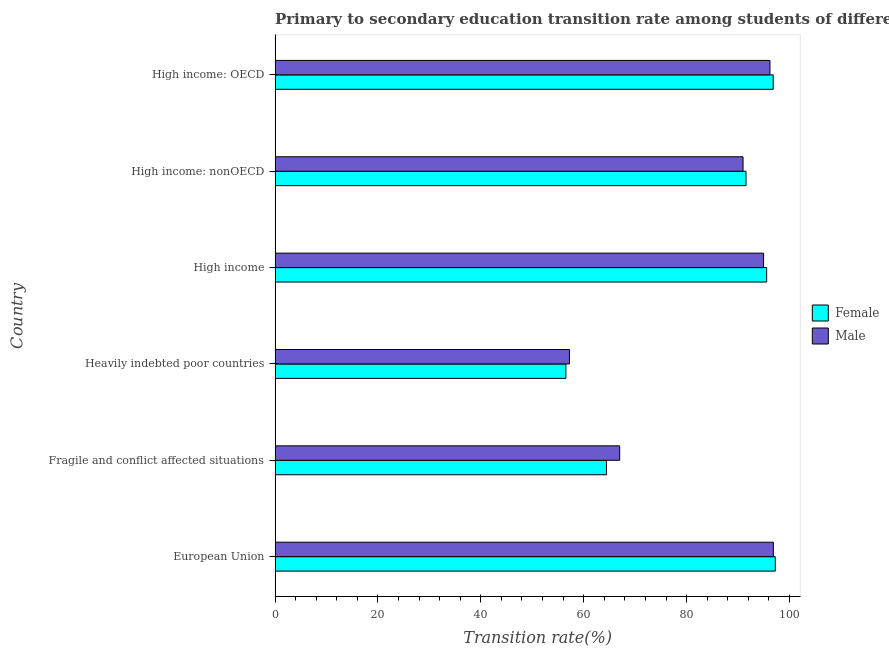How many different coloured bars are there?
Your answer should be compact. 2. How many groups of bars are there?
Give a very brief answer. 6. Are the number of bars per tick equal to the number of legend labels?
Offer a very short reply. Yes. How many bars are there on the 2nd tick from the top?
Offer a terse response. 2. What is the label of the 1st group of bars from the top?
Keep it short and to the point. High income: OECD. In how many cases, is the number of bars for a given country not equal to the number of legend labels?
Provide a short and direct response. 0. What is the transition rate among male students in High income: nonOECD?
Offer a very short reply. 90.97. Across all countries, what is the maximum transition rate among male students?
Make the answer very short. 96.87. Across all countries, what is the minimum transition rate among male students?
Provide a short and direct response. 57.23. In which country was the transition rate among female students minimum?
Keep it short and to the point. Heavily indebted poor countries. What is the total transition rate among female students in the graph?
Ensure brevity in your answer.  502.15. What is the difference between the transition rate among female students in Fragile and conflict affected situations and that in Heavily indebted poor countries?
Offer a very short reply. 7.88. What is the difference between the transition rate among female students in High income and the transition rate among male students in High income: OECD?
Provide a short and direct response. -0.64. What is the average transition rate among male students per country?
Make the answer very short. 83.87. What is the difference between the transition rate among female students and transition rate among male students in Heavily indebted poor countries?
Offer a terse response. -0.69. In how many countries, is the transition rate among female students greater than 96 %?
Your answer should be compact. 2. What is the ratio of the transition rate among female students in European Union to that in Heavily indebted poor countries?
Give a very brief answer. 1.72. Is the difference between the transition rate among female students in Fragile and conflict affected situations and High income: nonOECD greater than the difference between the transition rate among male students in Fragile and conflict affected situations and High income: nonOECD?
Offer a very short reply. No. What is the difference between the highest and the second highest transition rate among female students?
Keep it short and to the point. 0.41. What is the difference between the highest and the lowest transition rate among female students?
Offer a terse response. 40.71. Is the sum of the transition rate among male students in Heavily indebted poor countries and High income: nonOECD greater than the maximum transition rate among female students across all countries?
Your answer should be very brief. Yes. What does the 1st bar from the top in European Union represents?
Your answer should be very brief. Male. What does the 1st bar from the bottom in High income: OECD represents?
Give a very brief answer. Female. How many bars are there?
Keep it short and to the point. 12. Are all the bars in the graph horizontal?
Offer a very short reply. Yes. Are the values on the major ticks of X-axis written in scientific E-notation?
Your response must be concise. No. Where does the legend appear in the graph?
Keep it short and to the point. Center right. How are the legend labels stacked?
Your answer should be compact. Vertical. What is the title of the graph?
Offer a very short reply. Primary to secondary education transition rate among students of different countries. What is the label or title of the X-axis?
Your response must be concise. Transition rate(%). What is the label or title of the Y-axis?
Your response must be concise. Country. What is the Transition rate(%) of Female in European Union?
Make the answer very short. 97.24. What is the Transition rate(%) in Male in European Union?
Provide a succinct answer. 96.87. What is the Transition rate(%) of Female in Fragile and conflict affected situations?
Ensure brevity in your answer.  64.42. What is the Transition rate(%) of Male in Fragile and conflict affected situations?
Make the answer very short. 66.99. What is the Transition rate(%) of Female in Heavily indebted poor countries?
Keep it short and to the point. 56.54. What is the Transition rate(%) of Male in Heavily indebted poor countries?
Your answer should be compact. 57.23. What is the Transition rate(%) in Female in High income?
Provide a succinct answer. 95.56. What is the Transition rate(%) of Male in High income?
Offer a very short reply. 94.96. What is the Transition rate(%) of Female in High income: nonOECD?
Give a very brief answer. 91.55. What is the Transition rate(%) in Male in High income: nonOECD?
Your answer should be very brief. 90.97. What is the Transition rate(%) of Female in High income: OECD?
Provide a short and direct response. 96.84. What is the Transition rate(%) in Male in High income: OECD?
Make the answer very short. 96.2. Across all countries, what is the maximum Transition rate(%) in Female?
Provide a short and direct response. 97.24. Across all countries, what is the maximum Transition rate(%) of Male?
Ensure brevity in your answer.  96.87. Across all countries, what is the minimum Transition rate(%) of Female?
Give a very brief answer. 56.54. Across all countries, what is the minimum Transition rate(%) in Male?
Ensure brevity in your answer.  57.23. What is the total Transition rate(%) of Female in the graph?
Ensure brevity in your answer.  502.15. What is the total Transition rate(%) of Male in the graph?
Offer a terse response. 503.22. What is the difference between the Transition rate(%) of Female in European Union and that in Fragile and conflict affected situations?
Your answer should be very brief. 32.82. What is the difference between the Transition rate(%) in Male in European Union and that in Fragile and conflict affected situations?
Offer a very short reply. 29.88. What is the difference between the Transition rate(%) of Female in European Union and that in Heavily indebted poor countries?
Provide a succinct answer. 40.71. What is the difference between the Transition rate(%) in Male in European Union and that in Heavily indebted poor countries?
Your answer should be very brief. 39.64. What is the difference between the Transition rate(%) in Female in European Union and that in High income?
Offer a terse response. 1.68. What is the difference between the Transition rate(%) in Male in European Union and that in High income?
Ensure brevity in your answer.  1.91. What is the difference between the Transition rate(%) of Female in European Union and that in High income: nonOECD?
Make the answer very short. 5.69. What is the difference between the Transition rate(%) of Male in European Union and that in High income: nonOECD?
Your answer should be very brief. 5.89. What is the difference between the Transition rate(%) of Female in European Union and that in High income: OECD?
Your response must be concise. 0.41. What is the difference between the Transition rate(%) in Male in European Union and that in High income: OECD?
Ensure brevity in your answer.  0.66. What is the difference between the Transition rate(%) in Female in Fragile and conflict affected situations and that in Heavily indebted poor countries?
Your answer should be very brief. 7.89. What is the difference between the Transition rate(%) in Male in Fragile and conflict affected situations and that in Heavily indebted poor countries?
Give a very brief answer. 9.76. What is the difference between the Transition rate(%) of Female in Fragile and conflict affected situations and that in High income?
Your answer should be compact. -31.14. What is the difference between the Transition rate(%) of Male in Fragile and conflict affected situations and that in High income?
Make the answer very short. -27.97. What is the difference between the Transition rate(%) in Female in Fragile and conflict affected situations and that in High income: nonOECD?
Keep it short and to the point. -27.13. What is the difference between the Transition rate(%) of Male in Fragile and conflict affected situations and that in High income: nonOECD?
Offer a very short reply. -23.99. What is the difference between the Transition rate(%) in Female in Fragile and conflict affected situations and that in High income: OECD?
Give a very brief answer. -32.42. What is the difference between the Transition rate(%) in Male in Fragile and conflict affected situations and that in High income: OECD?
Provide a short and direct response. -29.22. What is the difference between the Transition rate(%) in Female in Heavily indebted poor countries and that in High income?
Provide a succinct answer. -39.03. What is the difference between the Transition rate(%) in Male in Heavily indebted poor countries and that in High income?
Your answer should be very brief. -37.73. What is the difference between the Transition rate(%) in Female in Heavily indebted poor countries and that in High income: nonOECD?
Offer a terse response. -35.01. What is the difference between the Transition rate(%) in Male in Heavily indebted poor countries and that in High income: nonOECD?
Provide a short and direct response. -33.74. What is the difference between the Transition rate(%) in Female in Heavily indebted poor countries and that in High income: OECD?
Keep it short and to the point. -40.3. What is the difference between the Transition rate(%) of Male in Heavily indebted poor countries and that in High income: OECD?
Your answer should be very brief. -38.97. What is the difference between the Transition rate(%) of Female in High income and that in High income: nonOECD?
Keep it short and to the point. 4.01. What is the difference between the Transition rate(%) of Male in High income and that in High income: nonOECD?
Your response must be concise. 3.99. What is the difference between the Transition rate(%) in Female in High income and that in High income: OECD?
Ensure brevity in your answer.  -1.27. What is the difference between the Transition rate(%) in Male in High income and that in High income: OECD?
Your response must be concise. -1.24. What is the difference between the Transition rate(%) of Female in High income: nonOECD and that in High income: OECD?
Your answer should be compact. -5.29. What is the difference between the Transition rate(%) of Male in High income: nonOECD and that in High income: OECD?
Offer a very short reply. -5.23. What is the difference between the Transition rate(%) of Female in European Union and the Transition rate(%) of Male in Fragile and conflict affected situations?
Offer a terse response. 30.25. What is the difference between the Transition rate(%) in Female in European Union and the Transition rate(%) in Male in Heavily indebted poor countries?
Your answer should be very brief. 40.01. What is the difference between the Transition rate(%) in Female in European Union and the Transition rate(%) in Male in High income?
Offer a very short reply. 2.28. What is the difference between the Transition rate(%) in Female in European Union and the Transition rate(%) in Male in High income: nonOECD?
Your response must be concise. 6.27. What is the difference between the Transition rate(%) in Female in European Union and the Transition rate(%) in Male in High income: OECD?
Make the answer very short. 1.04. What is the difference between the Transition rate(%) in Female in Fragile and conflict affected situations and the Transition rate(%) in Male in Heavily indebted poor countries?
Offer a very short reply. 7.19. What is the difference between the Transition rate(%) in Female in Fragile and conflict affected situations and the Transition rate(%) in Male in High income?
Your answer should be very brief. -30.54. What is the difference between the Transition rate(%) in Female in Fragile and conflict affected situations and the Transition rate(%) in Male in High income: nonOECD?
Keep it short and to the point. -26.55. What is the difference between the Transition rate(%) of Female in Fragile and conflict affected situations and the Transition rate(%) of Male in High income: OECD?
Provide a short and direct response. -31.78. What is the difference between the Transition rate(%) in Female in Heavily indebted poor countries and the Transition rate(%) in Male in High income?
Your answer should be compact. -38.43. What is the difference between the Transition rate(%) in Female in Heavily indebted poor countries and the Transition rate(%) in Male in High income: nonOECD?
Your answer should be compact. -34.44. What is the difference between the Transition rate(%) of Female in Heavily indebted poor countries and the Transition rate(%) of Male in High income: OECD?
Provide a short and direct response. -39.67. What is the difference between the Transition rate(%) in Female in High income and the Transition rate(%) in Male in High income: nonOECD?
Offer a terse response. 4.59. What is the difference between the Transition rate(%) of Female in High income and the Transition rate(%) of Male in High income: OECD?
Keep it short and to the point. -0.64. What is the difference between the Transition rate(%) in Female in High income: nonOECD and the Transition rate(%) in Male in High income: OECD?
Provide a succinct answer. -4.65. What is the average Transition rate(%) in Female per country?
Keep it short and to the point. 83.69. What is the average Transition rate(%) of Male per country?
Your answer should be very brief. 83.87. What is the difference between the Transition rate(%) of Female and Transition rate(%) of Male in European Union?
Ensure brevity in your answer.  0.38. What is the difference between the Transition rate(%) in Female and Transition rate(%) in Male in Fragile and conflict affected situations?
Provide a short and direct response. -2.57. What is the difference between the Transition rate(%) of Female and Transition rate(%) of Male in Heavily indebted poor countries?
Provide a short and direct response. -0.69. What is the difference between the Transition rate(%) of Female and Transition rate(%) of Male in High income?
Make the answer very short. 0.6. What is the difference between the Transition rate(%) in Female and Transition rate(%) in Male in High income: nonOECD?
Make the answer very short. 0.58. What is the difference between the Transition rate(%) of Female and Transition rate(%) of Male in High income: OECD?
Offer a very short reply. 0.63. What is the ratio of the Transition rate(%) of Female in European Union to that in Fragile and conflict affected situations?
Offer a terse response. 1.51. What is the ratio of the Transition rate(%) in Male in European Union to that in Fragile and conflict affected situations?
Your answer should be compact. 1.45. What is the ratio of the Transition rate(%) of Female in European Union to that in Heavily indebted poor countries?
Keep it short and to the point. 1.72. What is the ratio of the Transition rate(%) of Male in European Union to that in Heavily indebted poor countries?
Ensure brevity in your answer.  1.69. What is the ratio of the Transition rate(%) of Female in European Union to that in High income?
Give a very brief answer. 1.02. What is the ratio of the Transition rate(%) in Male in European Union to that in High income?
Your answer should be very brief. 1.02. What is the ratio of the Transition rate(%) in Female in European Union to that in High income: nonOECD?
Offer a terse response. 1.06. What is the ratio of the Transition rate(%) of Male in European Union to that in High income: nonOECD?
Your answer should be very brief. 1.06. What is the ratio of the Transition rate(%) of Female in European Union to that in High income: OECD?
Make the answer very short. 1. What is the ratio of the Transition rate(%) of Female in Fragile and conflict affected situations to that in Heavily indebted poor countries?
Give a very brief answer. 1.14. What is the ratio of the Transition rate(%) in Male in Fragile and conflict affected situations to that in Heavily indebted poor countries?
Offer a terse response. 1.17. What is the ratio of the Transition rate(%) in Female in Fragile and conflict affected situations to that in High income?
Give a very brief answer. 0.67. What is the ratio of the Transition rate(%) of Male in Fragile and conflict affected situations to that in High income?
Your answer should be very brief. 0.71. What is the ratio of the Transition rate(%) in Female in Fragile and conflict affected situations to that in High income: nonOECD?
Your answer should be very brief. 0.7. What is the ratio of the Transition rate(%) in Male in Fragile and conflict affected situations to that in High income: nonOECD?
Make the answer very short. 0.74. What is the ratio of the Transition rate(%) of Female in Fragile and conflict affected situations to that in High income: OECD?
Offer a terse response. 0.67. What is the ratio of the Transition rate(%) of Male in Fragile and conflict affected situations to that in High income: OECD?
Your answer should be very brief. 0.7. What is the ratio of the Transition rate(%) in Female in Heavily indebted poor countries to that in High income?
Your response must be concise. 0.59. What is the ratio of the Transition rate(%) in Male in Heavily indebted poor countries to that in High income?
Offer a terse response. 0.6. What is the ratio of the Transition rate(%) in Female in Heavily indebted poor countries to that in High income: nonOECD?
Make the answer very short. 0.62. What is the ratio of the Transition rate(%) of Male in Heavily indebted poor countries to that in High income: nonOECD?
Ensure brevity in your answer.  0.63. What is the ratio of the Transition rate(%) of Female in Heavily indebted poor countries to that in High income: OECD?
Ensure brevity in your answer.  0.58. What is the ratio of the Transition rate(%) in Male in Heavily indebted poor countries to that in High income: OECD?
Give a very brief answer. 0.59. What is the ratio of the Transition rate(%) in Female in High income to that in High income: nonOECD?
Your answer should be compact. 1.04. What is the ratio of the Transition rate(%) in Male in High income to that in High income: nonOECD?
Your answer should be very brief. 1.04. What is the ratio of the Transition rate(%) of Female in High income to that in High income: OECD?
Your answer should be very brief. 0.99. What is the ratio of the Transition rate(%) in Male in High income to that in High income: OECD?
Your answer should be compact. 0.99. What is the ratio of the Transition rate(%) of Female in High income: nonOECD to that in High income: OECD?
Your answer should be compact. 0.95. What is the ratio of the Transition rate(%) of Male in High income: nonOECD to that in High income: OECD?
Ensure brevity in your answer.  0.95. What is the difference between the highest and the second highest Transition rate(%) of Female?
Provide a short and direct response. 0.41. What is the difference between the highest and the second highest Transition rate(%) of Male?
Offer a terse response. 0.66. What is the difference between the highest and the lowest Transition rate(%) of Female?
Offer a very short reply. 40.71. What is the difference between the highest and the lowest Transition rate(%) in Male?
Your answer should be compact. 39.64. 